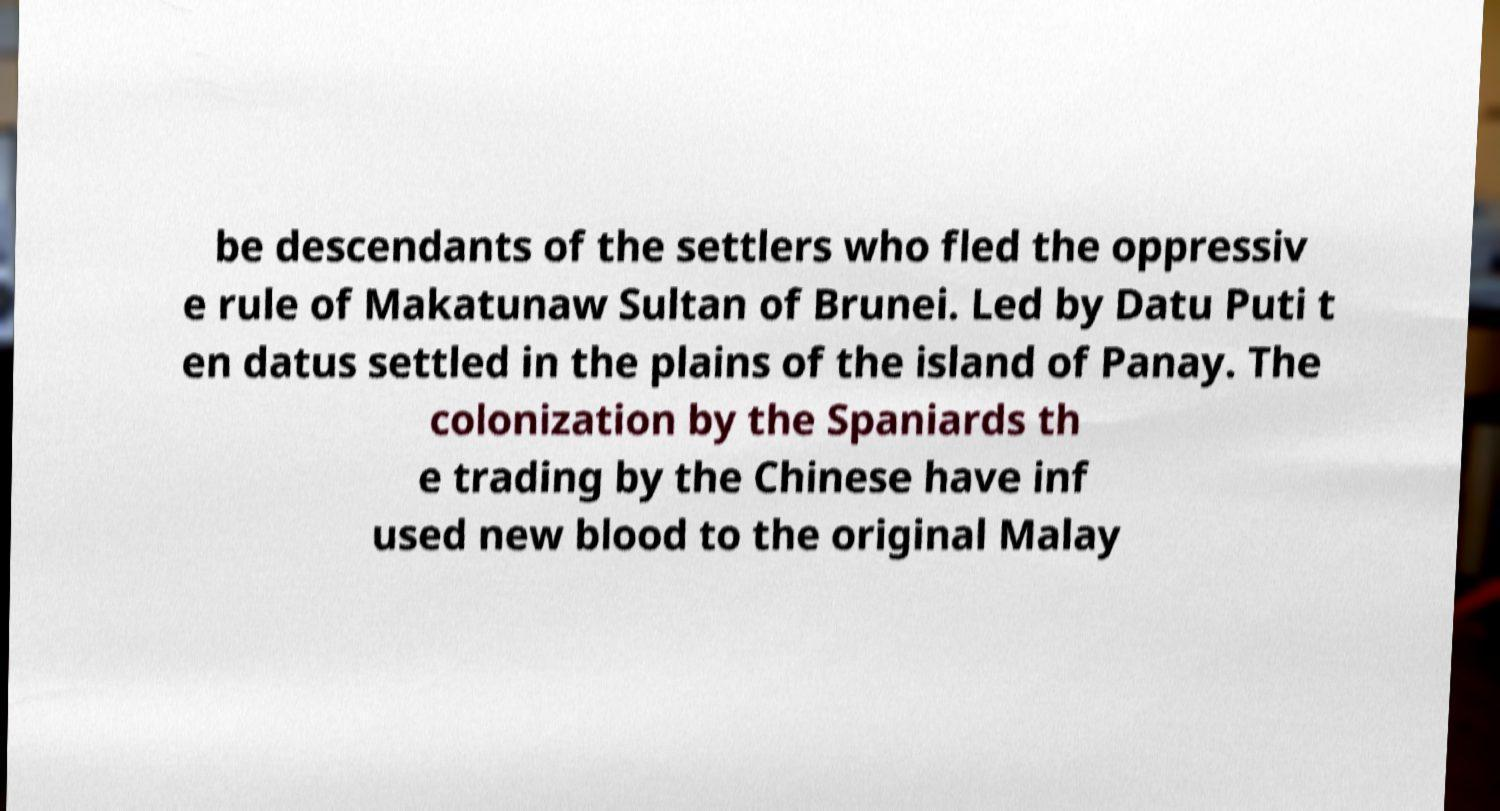Can you read and provide the text displayed in the image?This photo seems to have some interesting text. Can you extract and type it out for me? be descendants of the settlers who fled the oppressiv e rule of Makatunaw Sultan of Brunei. Led by Datu Puti t en datus settled in the plains of the island of Panay. The colonization by the Spaniards th e trading by the Chinese have inf used new blood to the original Malay 